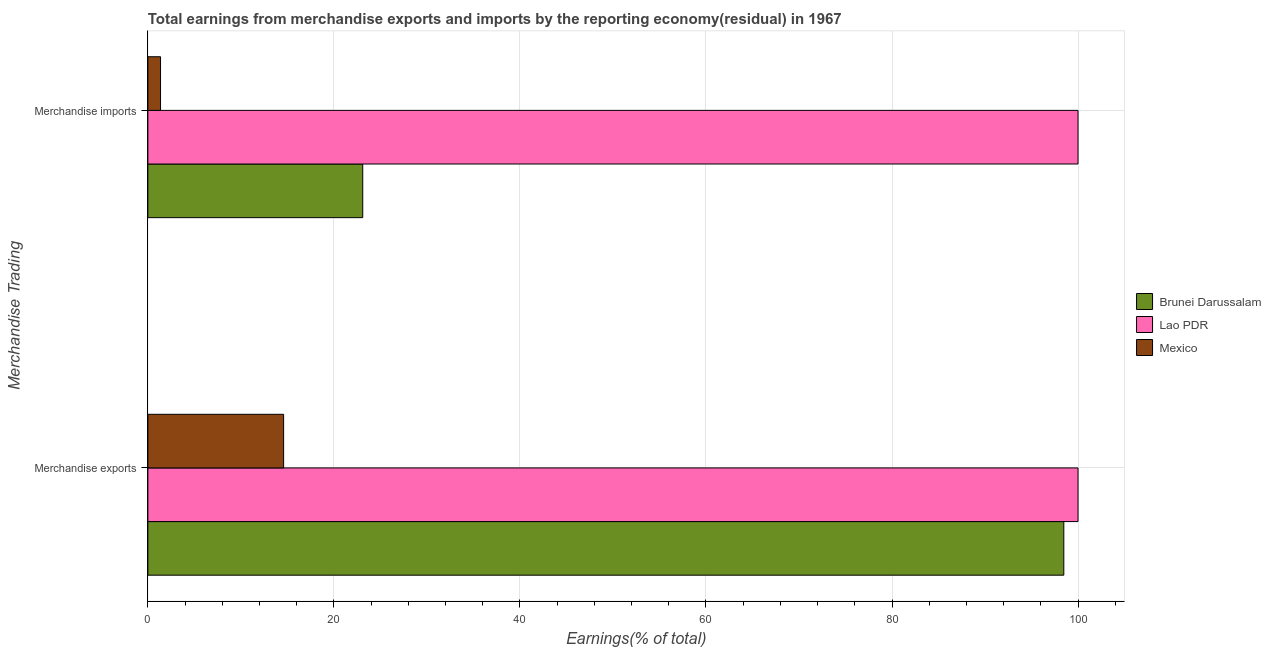How many groups of bars are there?
Your response must be concise. 2. Are the number of bars per tick equal to the number of legend labels?
Offer a very short reply. Yes. How many bars are there on the 2nd tick from the top?
Provide a succinct answer. 3. How many bars are there on the 1st tick from the bottom?
Give a very brief answer. 3. What is the label of the 2nd group of bars from the top?
Provide a short and direct response. Merchandise exports. What is the earnings from merchandise imports in Brunei Darussalam?
Provide a succinct answer. 23.1. Across all countries, what is the minimum earnings from merchandise imports?
Your answer should be compact. 1.36. In which country was the earnings from merchandise imports maximum?
Your response must be concise. Lao PDR. What is the total earnings from merchandise exports in the graph?
Your answer should be very brief. 213.07. What is the difference between the earnings from merchandise exports in Mexico and that in Lao PDR?
Offer a very short reply. -85.41. What is the difference between the earnings from merchandise exports in Lao PDR and the earnings from merchandise imports in Brunei Darussalam?
Provide a short and direct response. 76.9. What is the average earnings from merchandise exports per country?
Make the answer very short. 71.02. What is the ratio of the earnings from merchandise imports in Brunei Darussalam to that in Lao PDR?
Your response must be concise. 0.23. Is the earnings from merchandise exports in Brunei Darussalam less than that in Lao PDR?
Ensure brevity in your answer.  Yes. In how many countries, is the earnings from merchandise imports greater than the average earnings from merchandise imports taken over all countries?
Keep it short and to the point. 1. What does the 2nd bar from the top in Merchandise imports represents?
Give a very brief answer. Lao PDR. What does the 1st bar from the bottom in Merchandise exports represents?
Offer a terse response. Brunei Darussalam. How many bars are there?
Your response must be concise. 6. Are all the bars in the graph horizontal?
Give a very brief answer. Yes. Are the values on the major ticks of X-axis written in scientific E-notation?
Offer a terse response. No. Does the graph contain grids?
Your answer should be compact. Yes. Where does the legend appear in the graph?
Provide a succinct answer. Center right. How many legend labels are there?
Make the answer very short. 3. How are the legend labels stacked?
Your answer should be very brief. Vertical. What is the title of the graph?
Your response must be concise. Total earnings from merchandise exports and imports by the reporting economy(residual) in 1967. Does "Guinea-Bissau" appear as one of the legend labels in the graph?
Keep it short and to the point. No. What is the label or title of the X-axis?
Ensure brevity in your answer.  Earnings(% of total). What is the label or title of the Y-axis?
Keep it short and to the point. Merchandise Trading. What is the Earnings(% of total) in Brunei Darussalam in Merchandise exports?
Offer a terse response. 98.47. What is the Earnings(% of total) in Lao PDR in Merchandise exports?
Your response must be concise. 100. What is the Earnings(% of total) of Mexico in Merchandise exports?
Give a very brief answer. 14.59. What is the Earnings(% of total) of Brunei Darussalam in Merchandise imports?
Make the answer very short. 23.1. What is the Earnings(% of total) in Lao PDR in Merchandise imports?
Offer a very short reply. 100. What is the Earnings(% of total) in Mexico in Merchandise imports?
Provide a succinct answer. 1.36. Across all Merchandise Trading, what is the maximum Earnings(% of total) in Brunei Darussalam?
Ensure brevity in your answer.  98.47. Across all Merchandise Trading, what is the maximum Earnings(% of total) in Mexico?
Make the answer very short. 14.59. Across all Merchandise Trading, what is the minimum Earnings(% of total) in Brunei Darussalam?
Make the answer very short. 23.1. Across all Merchandise Trading, what is the minimum Earnings(% of total) in Lao PDR?
Make the answer very short. 100. Across all Merchandise Trading, what is the minimum Earnings(% of total) of Mexico?
Ensure brevity in your answer.  1.36. What is the total Earnings(% of total) in Brunei Darussalam in the graph?
Provide a succinct answer. 121.57. What is the total Earnings(% of total) in Lao PDR in the graph?
Offer a terse response. 200. What is the total Earnings(% of total) in Mexico in the graph?
Make the answer very short. 15.96. What is the difference between the Earnings(% of total) in Brunei Darussalam in Merchandise exports and that in Merchandise imports?
Offer a very short reply. 75.37. What is the difference between the Earnings(% of total) of Mexico in Merchandise exports and that in Merchandise imports?
Your response must be concise. 13.23. What is the difference between the Earnings(% of total) of Brunei Darussalam in Merchandise exports and the Earnings(% of total) of Lao PDR in Merchandise imports?
Make the answer very short. -1.53. What is the difference between the Earnings(% of total) in Brunei Darussalam in Merchandise exports and the Earnings(% of total) in Mexico in Merchandise imports?
Your response must be concise. 97.11. What is the difference between the Earnings(% of total) in Lao PDR in Merchandise exports and the Earnings(% of total) in Mexico in Merchandise imports?
Offer a very short reply. 98.64. What is the average Earnings(% of total) of Brunei Darussalam per Merchandise Trading?
Ensure brevity in your answer.  60.79. What is the average Earnings(% of total) of Lao PDR per Merchandise Trading?
Give a very brief answer. 100. What is the average Earnings(% of total) of Mexico per Merchandise Trading?
Provide a short and direct response. 7.98. What is the difference between the Earnings(% of total) in Brunei Darussalam and Earnings(% of total) in Lao PDR in Merchandise exports?
Give a very brief answer. -1.53. What is the difference between the Earnings(% of total) of Brunei Darussalam and Earnings(% of total) of Mexico in Merchandise exports?
Offer a terse response. 83.88. What is the difference between the Earnings(% of total) of Lao PDR and Earnings(% of total) of Mexico in Merchandise exports?
Your answer should be very brief. 85.41. What is the difference between the Earnings(% of total) of Brunei Darussalam and Earnings(% of total) of Lao PDR in Merchandise imports?
Your response must be concise. -76.9. What is the difference between the Earnings(% of total) in Brunei Darussalam and Earnings(% of total) in Mexico in Merchandise imports?
Make the answer very short. 21.74. What is the difference between the Earnings(% of total) of Lao PDR and Earnings(% of total) of Mexico in Merchandise imports?
Your answer should be very brief. 98.64. What is the ratio of the Earnings(% of total) in Brunei Darussalam in Merchandise exports to that in Merchandise imports?
Your answer should be very brief. 4.26. What is the ratio of the Earnings(% of total) in Mexico in Merchandise exports to that in Merchandise imports?
Provide a short and direct response. 10.72. What is the difference between the highest and the second highest Earnings(% of total) in Brunei Darussalam?
Your response must be concise. 75.37. What is the difference between the highest and the second highest Earnings(% of total) in Mexico?
Your response must be concise. 13.23. What is the difference between the highest and the lowest Earnings(% of total) of Brunei Darussalam?
Offer a very short reply. 75.37. What is the difference between the highest and the lowest Earnings(% of total) in Mexico?
Provide a succinct answer. 13.23. 